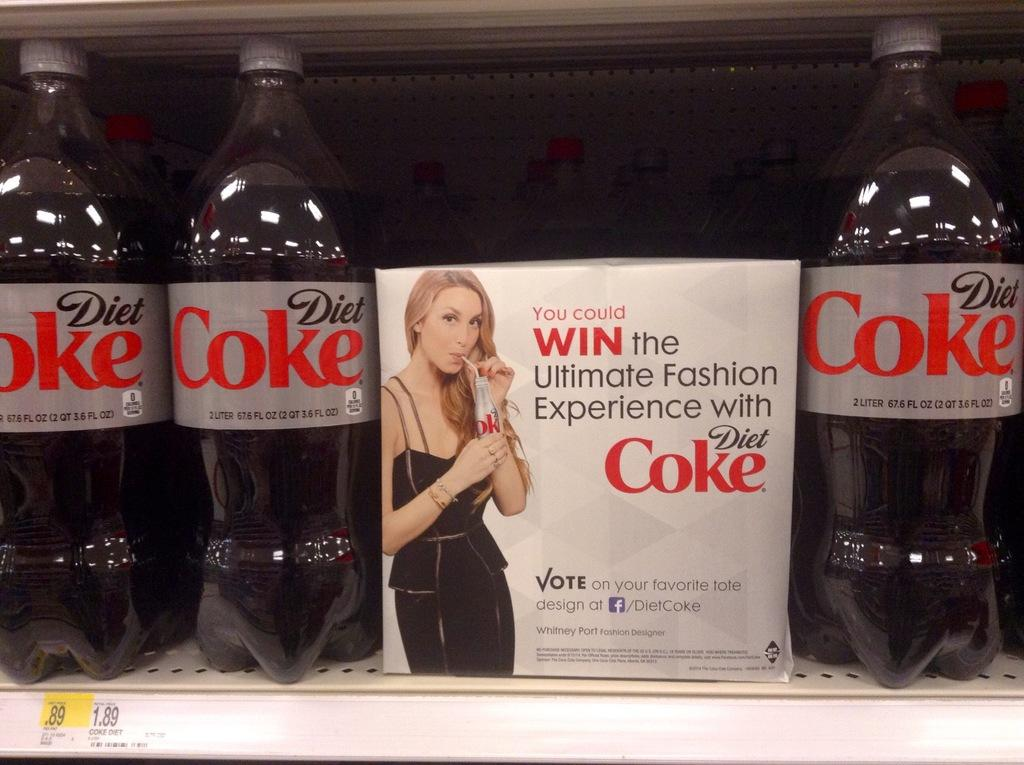How many bottles are visible on the rack in the image? There are three bottles on a rack in the image. What other object can be seen in the image besides the bottles? There is a box in the image. Can you describe the image on the box? The image on the box depicts a woman. What type of camera is being used to take a picture of the bottles in the image? There is no camera present in the image, as it only shows the bottles on the rack and the box with the woman's image. Is there a chain visible in the image connecting the bottles to the rack? There is no chain present in the image. 